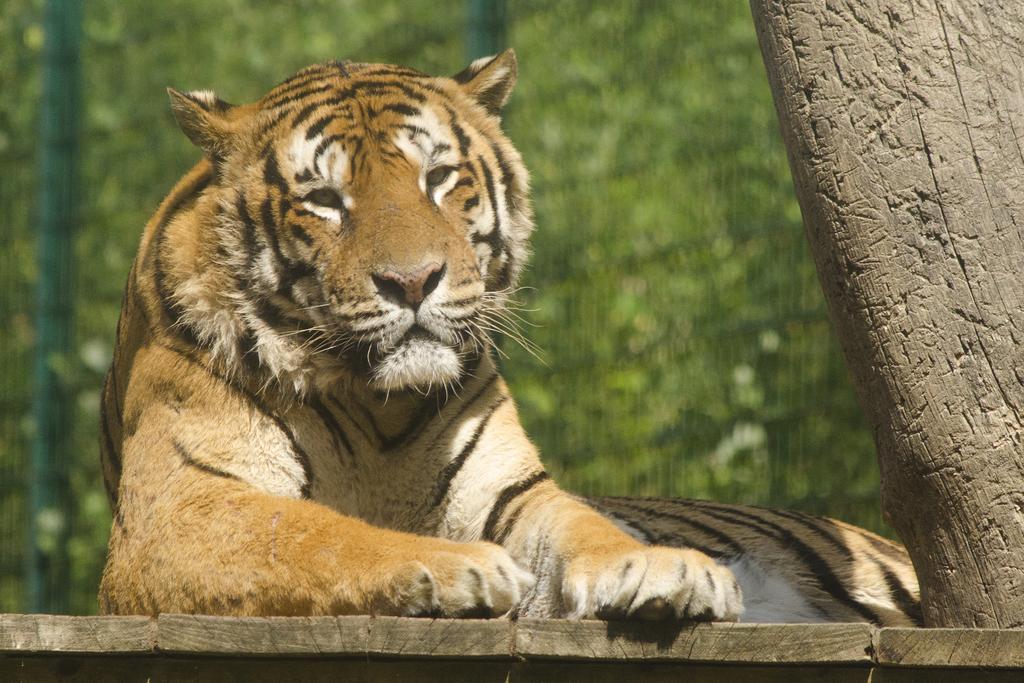Describe this image in one or two sentences. In this image I can see a tiger in the front and I can also see green colour in the background. On the right side of the image I can see a thing. 